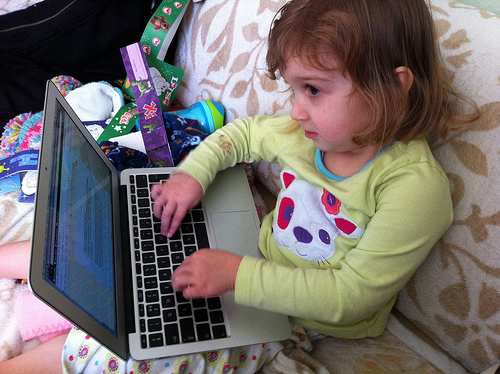<image>
Is the baby under the laptop? No. The baby is not positioned under the laptop. The vertical relationship between these objects is different. 